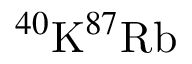Convert formula to latex. <formula><loc_0><loc_0><loc_500><loc_500>^ { 4 0 } K ^ { 8 7 } R b</formula> 